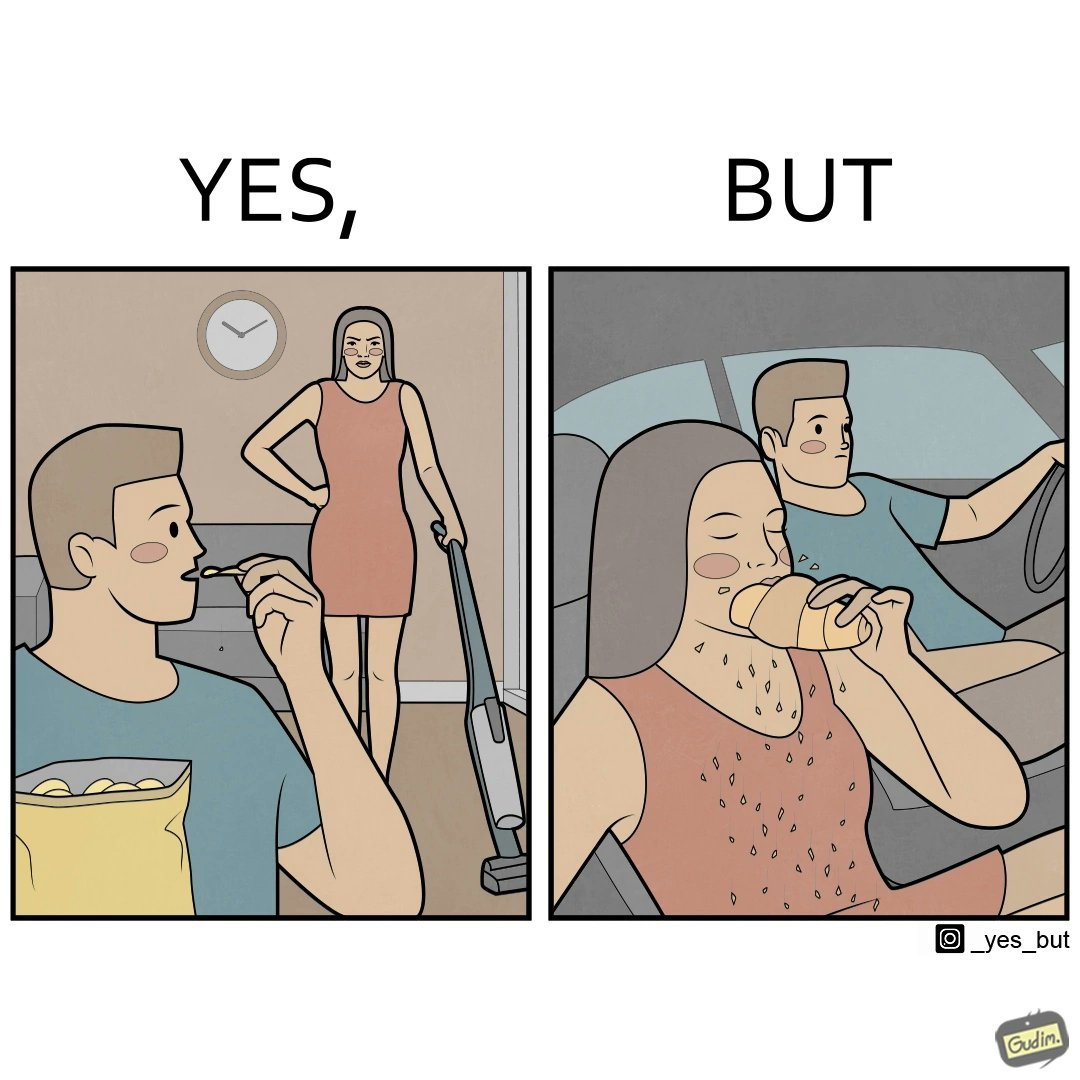What makes this image funny or satirical? The image is ironic, because in the left image she is seen how sincere she is about keeping her home clean but in the right image she forgets these principles while travelling in the car 